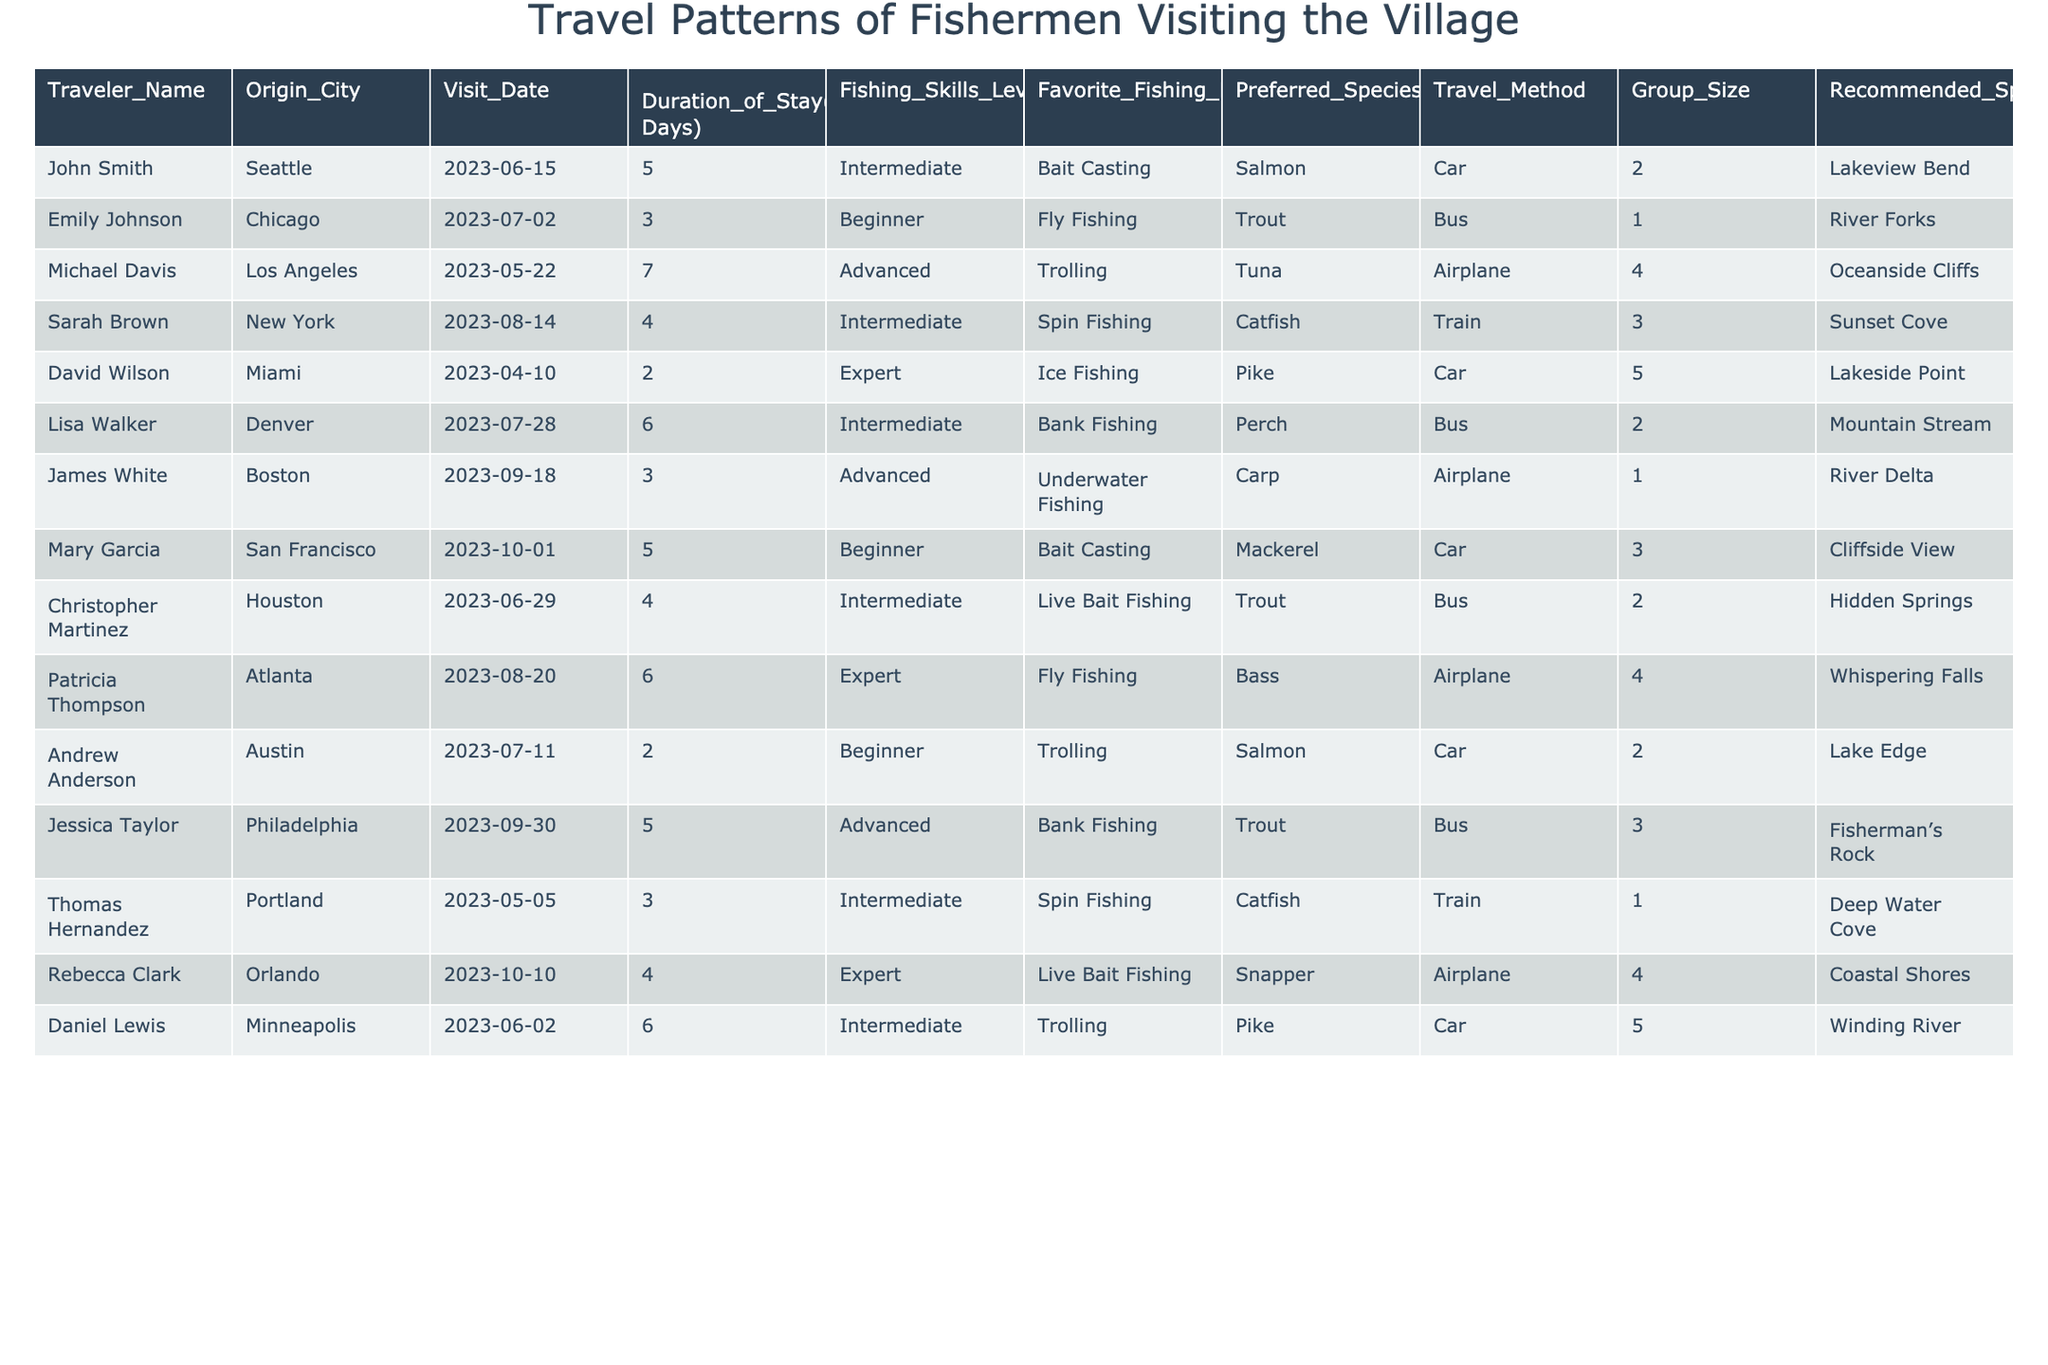What is the favorite fishing method of John Smith? The table states that John Smith's favorite fishing method is Bait Casting.
Answer: Bait Casting How many days did Michael Davis stay in the village? Michael Davis stayed for 7 days, as indicated in the Duration of Stay column.
Answer: 7 What species do beginners tend to prefer when fishing? The table shows that both Emily Johnson and Mary Garcia, who are beginners, prefer Trout and Mackerel respectively. Trout seems to be favored among other beginners based on the table.
Answer: Trout Which traveler visited from Miami, and what was their fishing skill level? The table indicates that David Wilson visited from Miami and is classified as an Expert in fishing skills.
Answer: David Wilson, Expert How many fishing days did the traveler from New York stay? Sarah Brown, the traveler from New York, stayed for 4 fishing days as shown in the table.
Answer: 4 Is there any traveler who preferred Ice Fishing? Yes, David Wilson preferred Ice Fishing based on the data.
Answer: Yes How many travelers in total are classified as Advanced? The table lists three travelers classified as Advanced: Michael Davis, James White, and Jessica Taylor. Therefore, the total is 3.
Answer: 3 Which travel method was the most common among the visitors? Analyzing the Travel Method column, 'Car' appears 5 times, which is the highest among other methods.
Answer: Car What is the average duration of stay for travelers who prefer Bank Fishing? The average stay for Lisa Walker (6 days) and Jessica Taylor (5 days) is (6 + 5) / 2 = 5.5 days.
Answer: 5.5 Did any travelers visit from Atlanta, and if so, what was their group size? Yes, Patricia Thompson visited from Atlanta, and her group size was 4 as indicated in the Group Size column.
Answer: Yes, 4 Which fishing spot was recommended for travelers coming from Chicago and Miami? For Chicago, River Forks is recommended, and for Miami, Lakeside Point is recommended for David Wilson.
Answer: River Forks and Lakeside Point How does the fishing skills level of travelers from Seattle and Boston compare? John Smith from Seattle has an Intermediate level, whereas James White from Boston has an Advanced level, indicating one has a higher skill level than the other.
Answer: James White is more skilled 